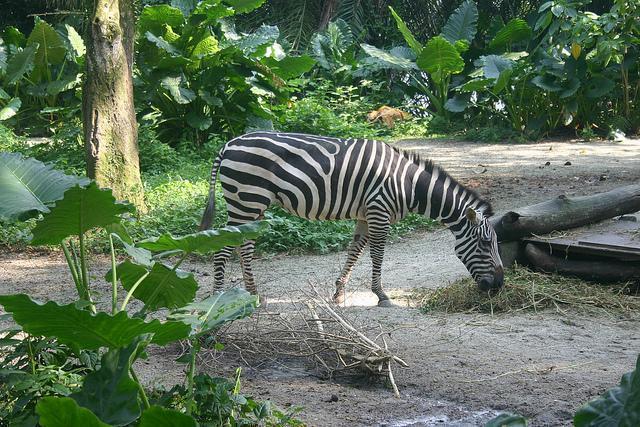How many zebras are shown?
Give a very brief answer. 1. How many zebras can you see?
Give a very brief answer. 1. How many red bikes are there?
Give a very brief answer. 0. 